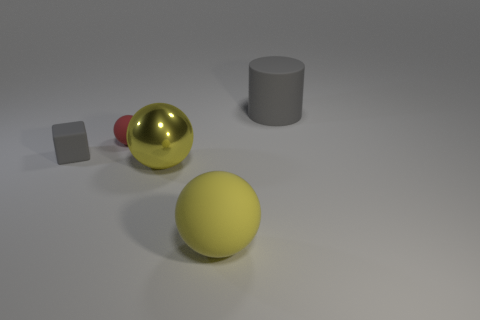There is a small cube; does it have the same color as the large object that is behind the small gray rubber cube?
Make the answer very short. Yes. Are there any other things that have the same color as the tiny matte sphere?
Give a very brief answer. No. What is the shape of the yellow thing behind the rubber ball that is right of the small thing that is behind the small gray matte object?
Offer a very short reply. Sphere. There is a yellow object to the right of the big yellow metallic thing; is it the same size as the matte thing that is left of the red ball?
Make the answer very short. No. How many other red objects have the same material as the small red thing?
Ensure brevity in your answer.  0. How many tiny red spheres are to the right of the tiny matte thing right of the gray object to the left of the big matte cylinder?
Keep it short and to the point. 0. Is the shape of the red object the same as the large yellow metal thing?
Give a very brief answer. Yes. Is there a small gray rubber thing that has the same shape as the big gray object?
Your answer should be very brief. No. What is the shape of the yellow object that is the same size as the yellow metallic sphere?
Your answer should be very brief. Sphere. What is the material of the yellow thing that is behind the big rubber object that is in front of the gray matte object that is in front of the gray matte cylinder?
Provide a short and direct response. Metal. 